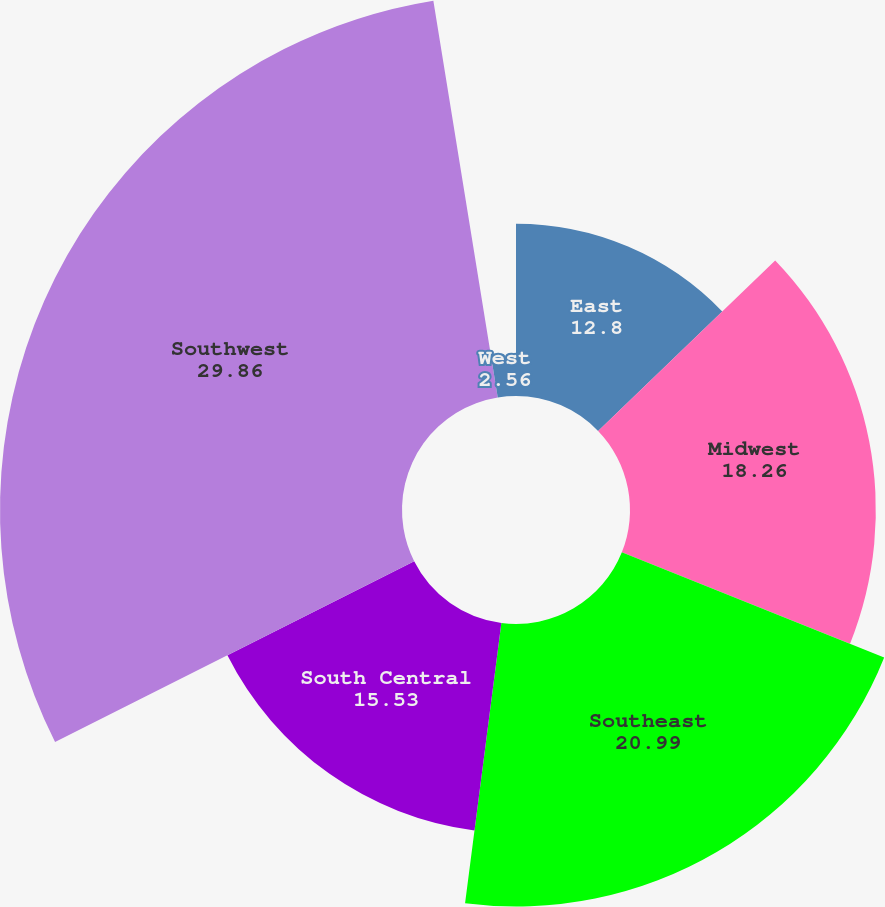<chart> <loc_0><loc_0><loc_500><loc_500><pie_chart><fcel>East<fcel>Midwest<fcel>Southeast<fcel>South Central<fcel>Southwest<fcel>West<nl><fcel>12.8%<fcel>18.26%<fcel>20.99%<fcel>15.53%<fcel>29.86%<fcel>2.56%<nl></chart> 